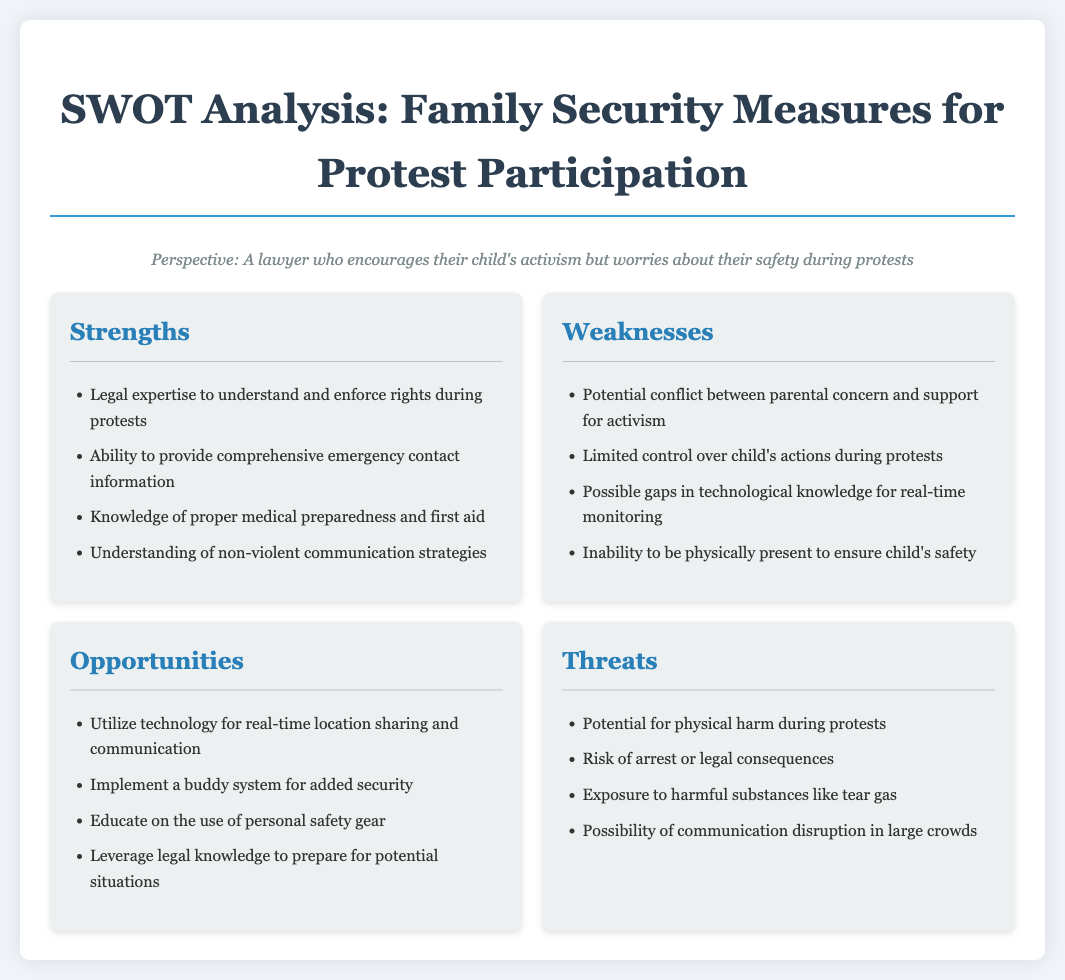what is the title of the document? The title is found at the top of the document and introduces the topic of the analysis.
Answer: SWOT Analysis: Family Security Measures for Protest Participation how many sections are in the SWOT analysis? The SWOT analysis is divided into four sections: Strengths, Weaknesses, Opportunities, and Threats.
Answer: Four what legal expertise is mentioned as a strength? The strength section lists various legal capabilities; the specific expertise refers to understanding rights during protests.
Answer: Legal expertise to understand and enforce rights during protests what is a weakness related to parental control? One of the weaknesses addresses the challenge parents face regarding their children's actions during protests.
Answer: Limited control over child's actions during protests name one opportunity listed for improving safety. The opportunities section provides various options for enhancing security; one specific opportunity involves technology.
Answer: Utilize technology for real-time location sharing and communication what is a specific threat mentioned regarding protests? The threats section outlines potential dangers associated with protests, including possible legal issues.
Answer: Risk of arrest or legal consequences which strength pertains to medical preparedness? The strengths include knowledge related to health and emergencies that might arise during protests.
Answer: Knowledge of proper medical preparedness and first aid how does the document describe a potential conflict for parents? The document addresses the emotional difficulty parents might face when supporting their child's activism while worrying about safety.
Answer: Potential conflict between parental concern and support for activism 